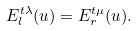Convert formula to latex. <formula><loc_0><loc_0><loc_500><loc_500>E _ { l } ^ { t \lambda } ( u ) = E _ { r } ^ { t \mu } ( u ) .</formula> 